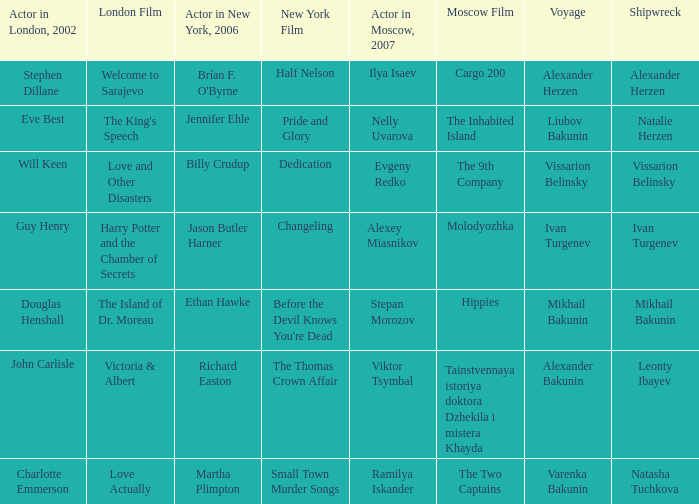Write the full table. {'header': ['Actor in London, 2002', 'London Film', 'Actor in New York, 2006', 'New York Film', 'Actor in Moscow, 2007', 'Moscow Film', 'Voyage', 'Shipwreck'], 'rows': [['Stephen Dillane', 'Welcome to Sarajevo', "Brían F. O'Byrne", 'Half Nelson', 'Ilya Isaev', 'Cargo 200', 'Alexander Herzen', 'Alexander Herzen'], ['Eve Best', "The King's Speech", 'Jennifer Ehle', 'Pride and Glory', 'Nelly Uvarova', 'The Inhabited Island', 'Liubov Bakunin', 'Natalie Herzen'], ['Will Keen', 'Love and Other Disasters', 'Billy Crudup', 'Dedication', 'Evgeny Redko', 'The 9th Company', 'Vissarion Belinsky', 'Vissarion Belinsky'], ['Guy Henry', 'Harry Potter and the Chamber of Secrets', 'Jason Butler Harner', 'Changeling', 'Alexey Miasnikov', 'Molodyozhka', 'Ivan Turgenev', 'Ivan Turgenev'], ['Douglas Henshall', 'The Island of Dr. Moreau', 'Ethan Hawke', "Before the Devil Knows You're Dead", 'Stepan Morozov', 'Hippies', 'Mikhail Bakunin', 'Mikhail Bakunin'], ['John Carlisle', 'Victoria & Albert', 'Richard Easton', 'The Thomas Crown Affair', 'Viktor Tsymbal', 'Tainstvennaya istoriya doktora Dzhekila i mistera Khayda', 'Alexander Bakunin', 'Leonty Ibayev'], ['Charlotte Emmerson', 'Love Actually', 'Martha Plimpton', 'Small Town Murder Songs', 'Ramilya Iskander', 'The Two Captains', 'Varenka Bakunin', 'Natasha Tuchkova']]} During the 2002 leonty ibayev shipwreck in london, who was the actor present? John Carlisle. 